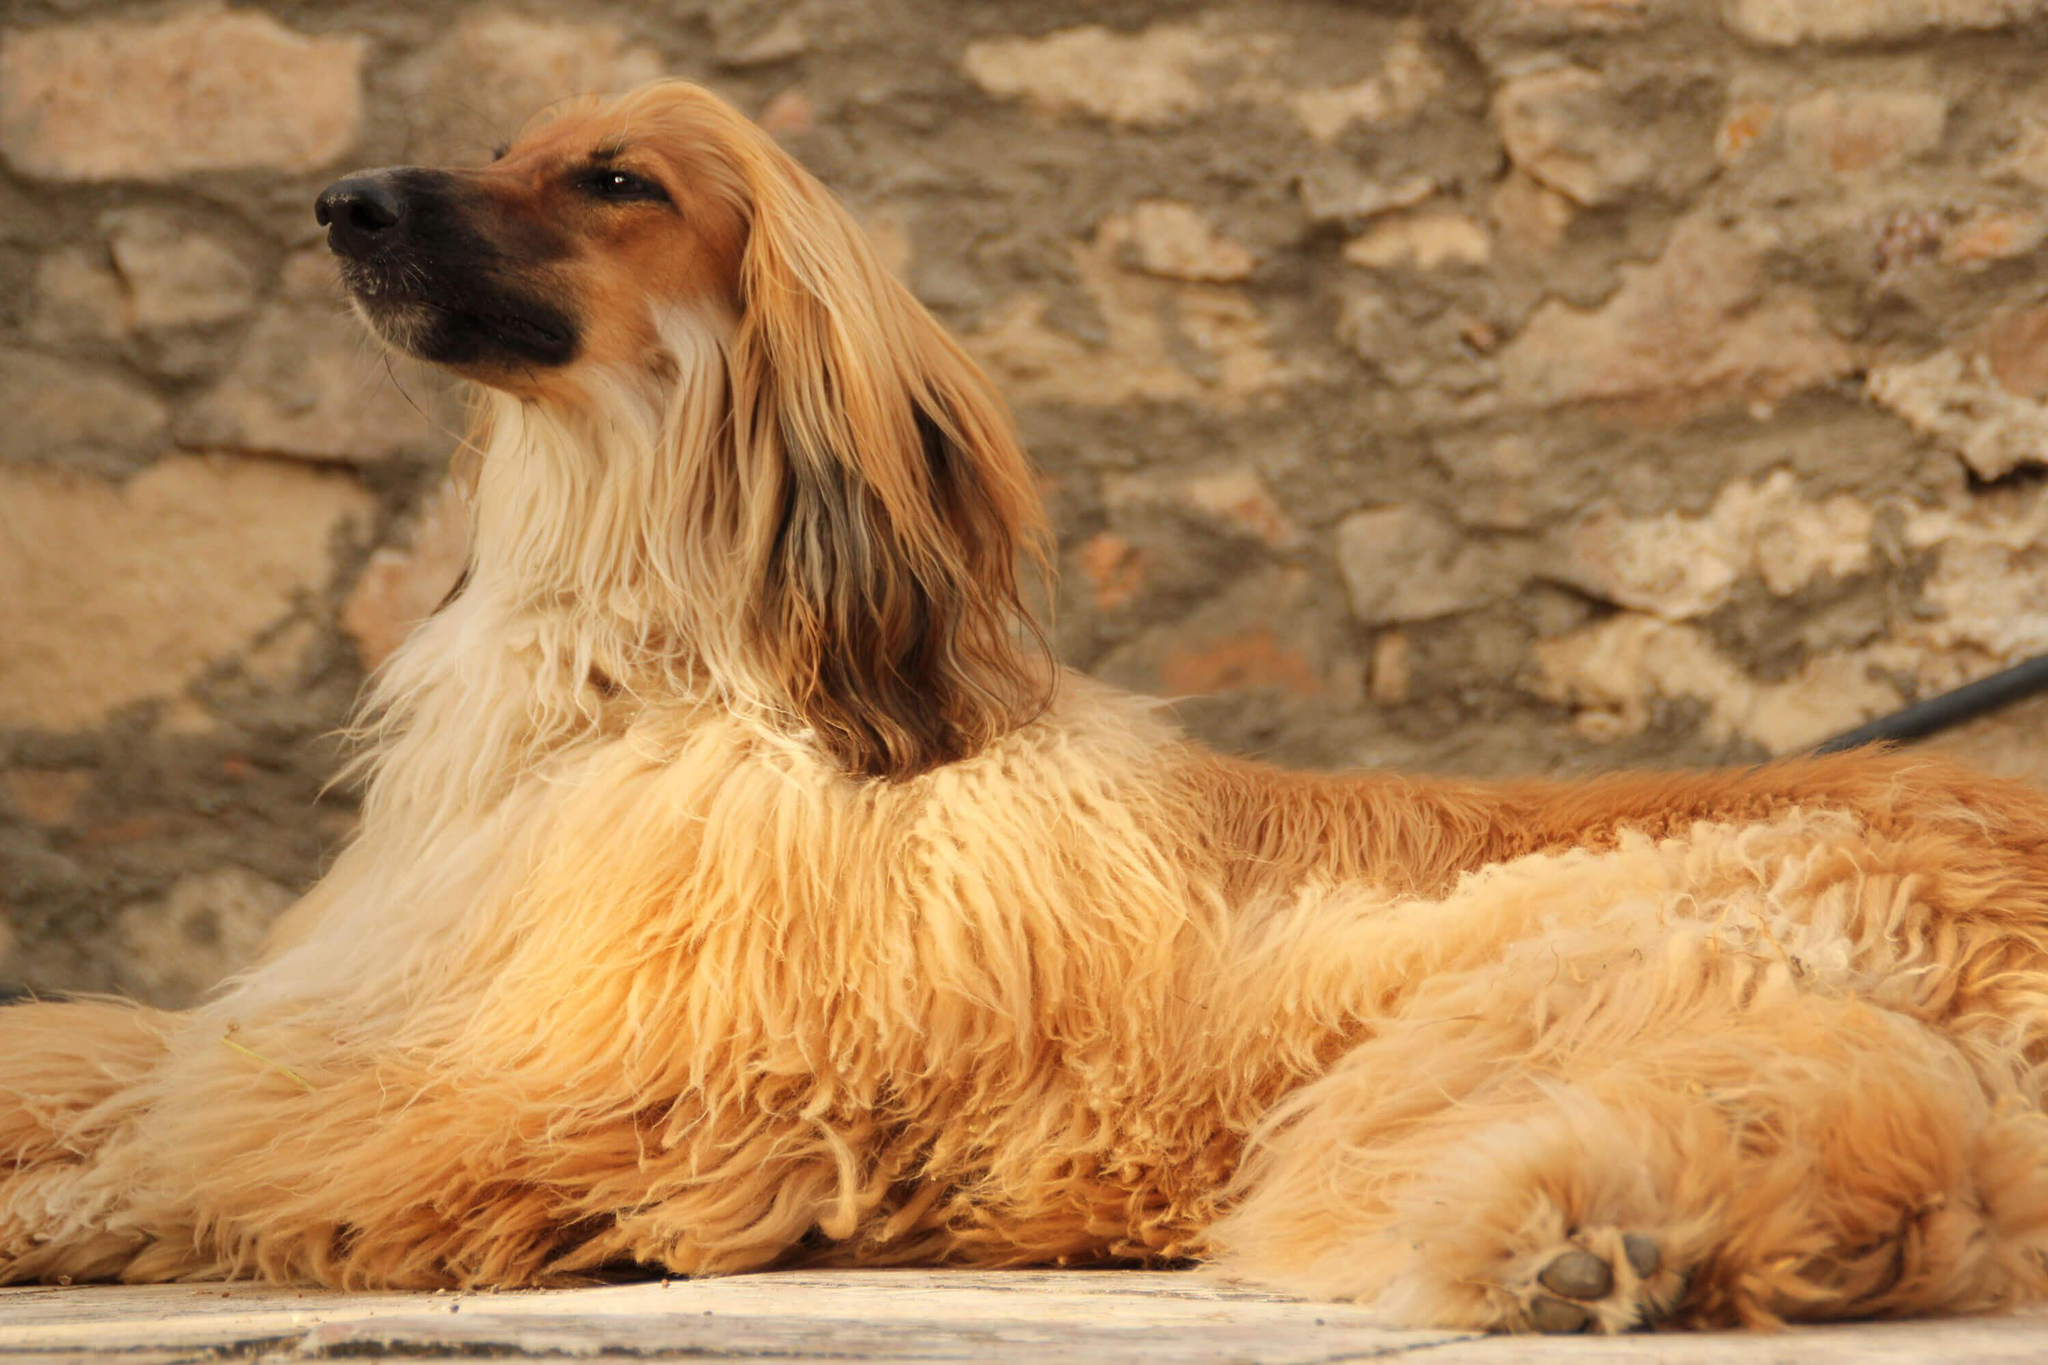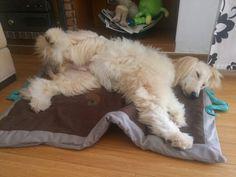The first image is the image on the left, the second image is the image on the right. Assess this claim about the two images: "An image shows a hound sleeping on a solid-white fabric-covered furniture item.". Correct or not? Answer yes or no. No. The first image is the image on the left, the second image is the image on the right. Analyze the images presented: Is the assertion "In one image, a large light colored dog with very long hair is lounging on the arm of an overstuffed chair inside a home." valid? Answer yes or no. No. 